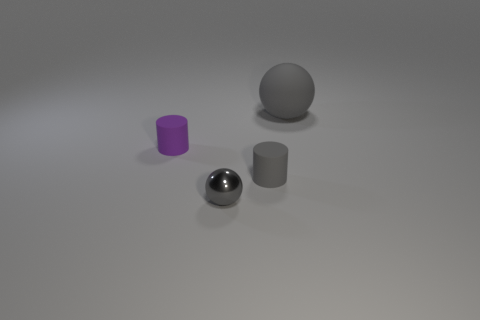How many gray spheres must be subtracted to get 1 gray spheres? 1 Add 1 purple cylinders. How many objects exist? 5 Add 2 blocks. How many blocks exist? 2 Subtract 0 yellow cubes. How many objects are left? 4 Subtract all large spheres. Subtract all small cylinders. How many objects are left? 1 Add 4 shiny spheres. How many shiny spheres are left? 5 